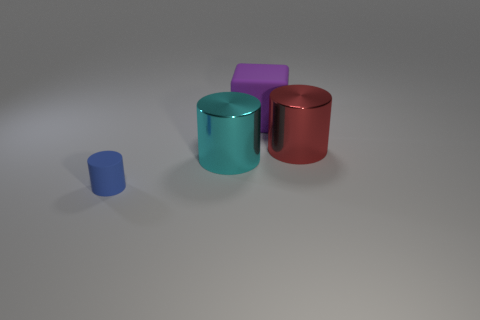Add 4 large green rubber blocks. How many objects exist? 8 Subtract all cylinders. How many objects are left? 1 Add 4 matte cylinders. How many matte cylinders exist? 5 Subtract 0 gray cubes. How many objects are left? 4 Subtract all large matte spheres. Subtract all matte things. How many objects are left? 2 Add 3 red cylinders. How many red cylinders are left? 4 